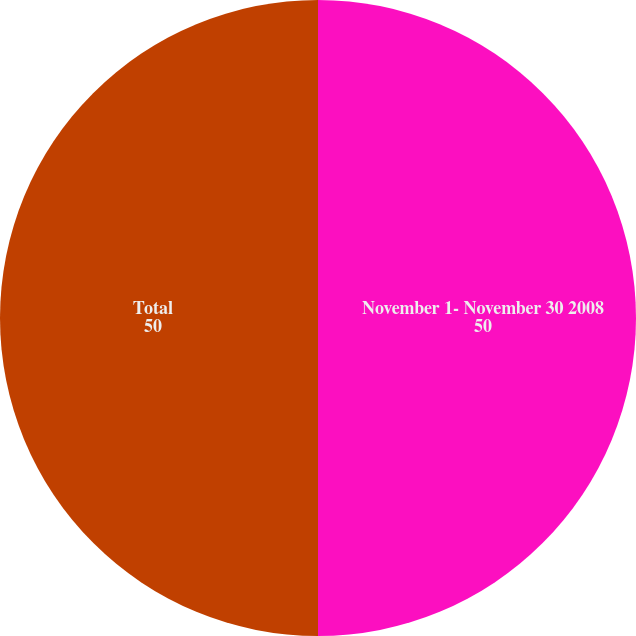<chart> <loc_0><loc_0><loc_500><loc_500><pie_chart><fcel>November 1- November 30 2008<fcel>Total<nl><fcel>50.0%<fcel>50.0%<nl></chart> 